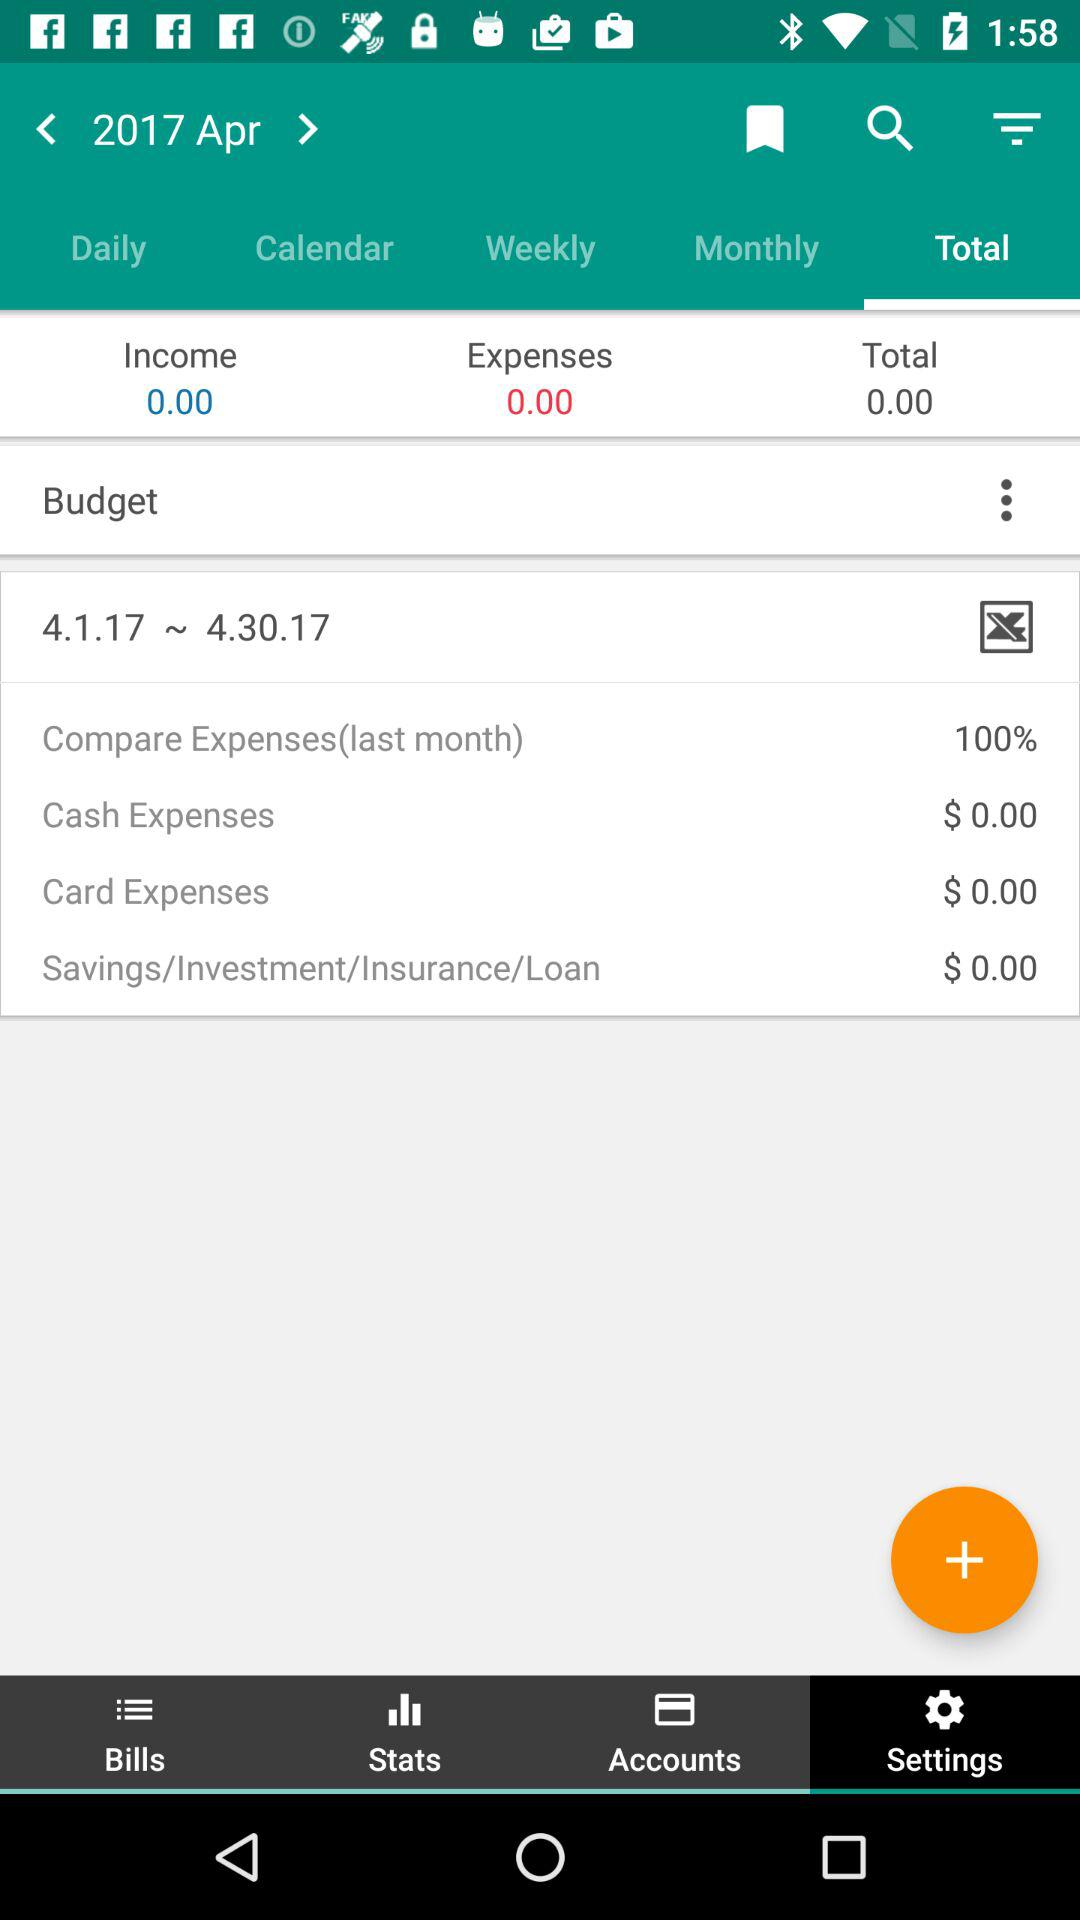What is the total amount of cash expenses?
Answer the question using a single word or phrase. $ 0.00 